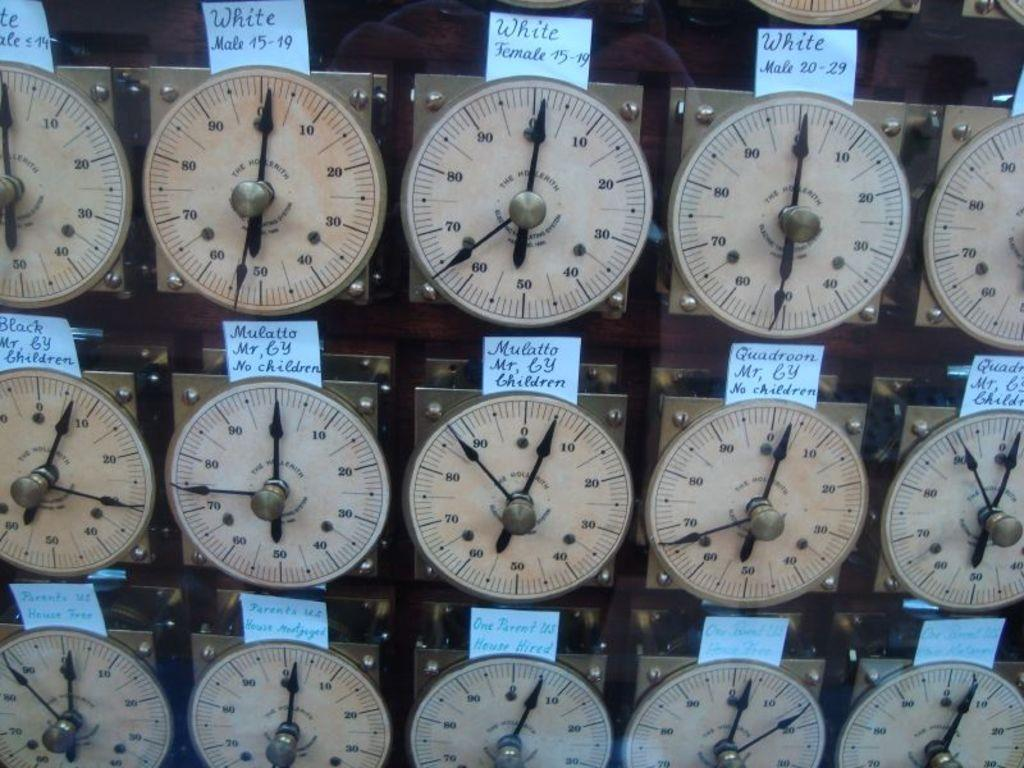What type of objects are present in the image? There are multiple meters in the image. What feature do the meters have in common? Each meter has two black needles. Are there any labels or identifiers on the meters? Yes, there are name boards on each meter. Can you see a fight happening in the image? No, there is no fight depicted in the image; it features multiple meters with black needles and name boards. 